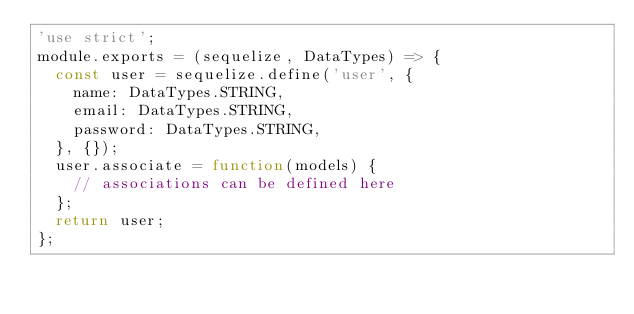<code> <loc_0><loc_0><loc_500><loc_500><_JavaScript_>'use strict';
module.exports = (sequelize, DataTypes) => {
  const user = sequelize.define('user', {
    name: DataTypes.STRING,
    email: DataTypes.STRING,
    password: DataTypes.STRING,
  }, {});
  user.associate = function(models) {
    // associations can be defined here
  };
  return user;
};</code> 